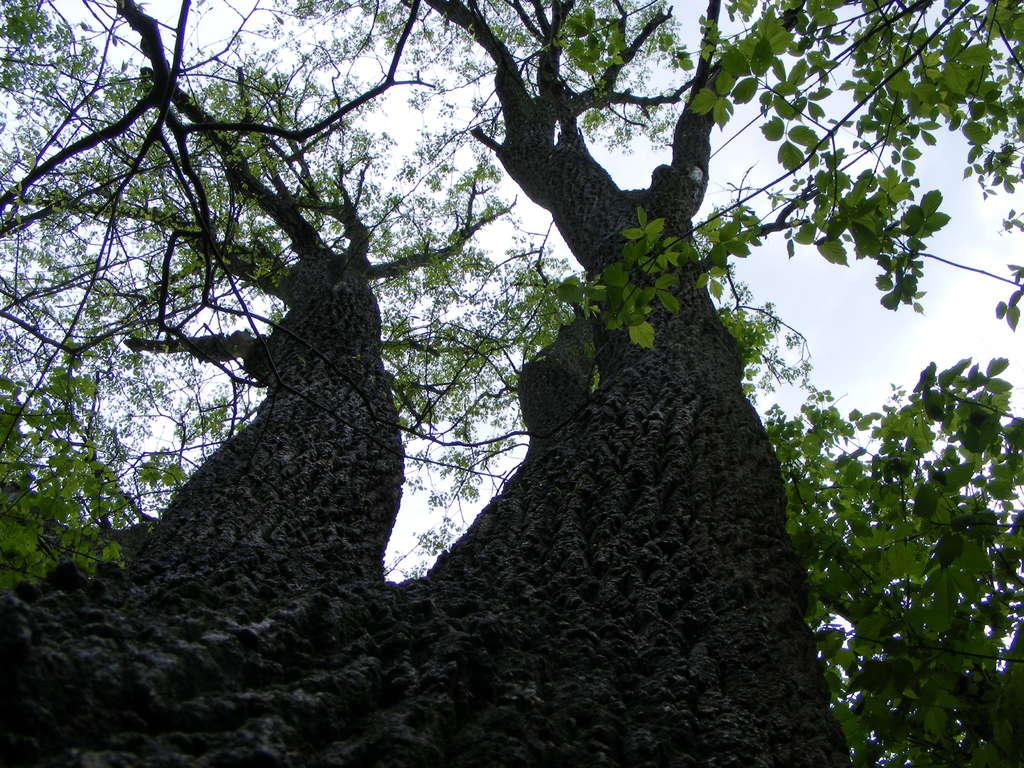What type of vegetation is present in the front of the image? There are trees and leaves in the front of the image. What part of the natural environment is visible in the image? The sky is visible at the top of the image. What type of fear can be seen on the self in the image? There is no fear or self present in the image; it features trees and leaves in the front and the sky visible at the top. 